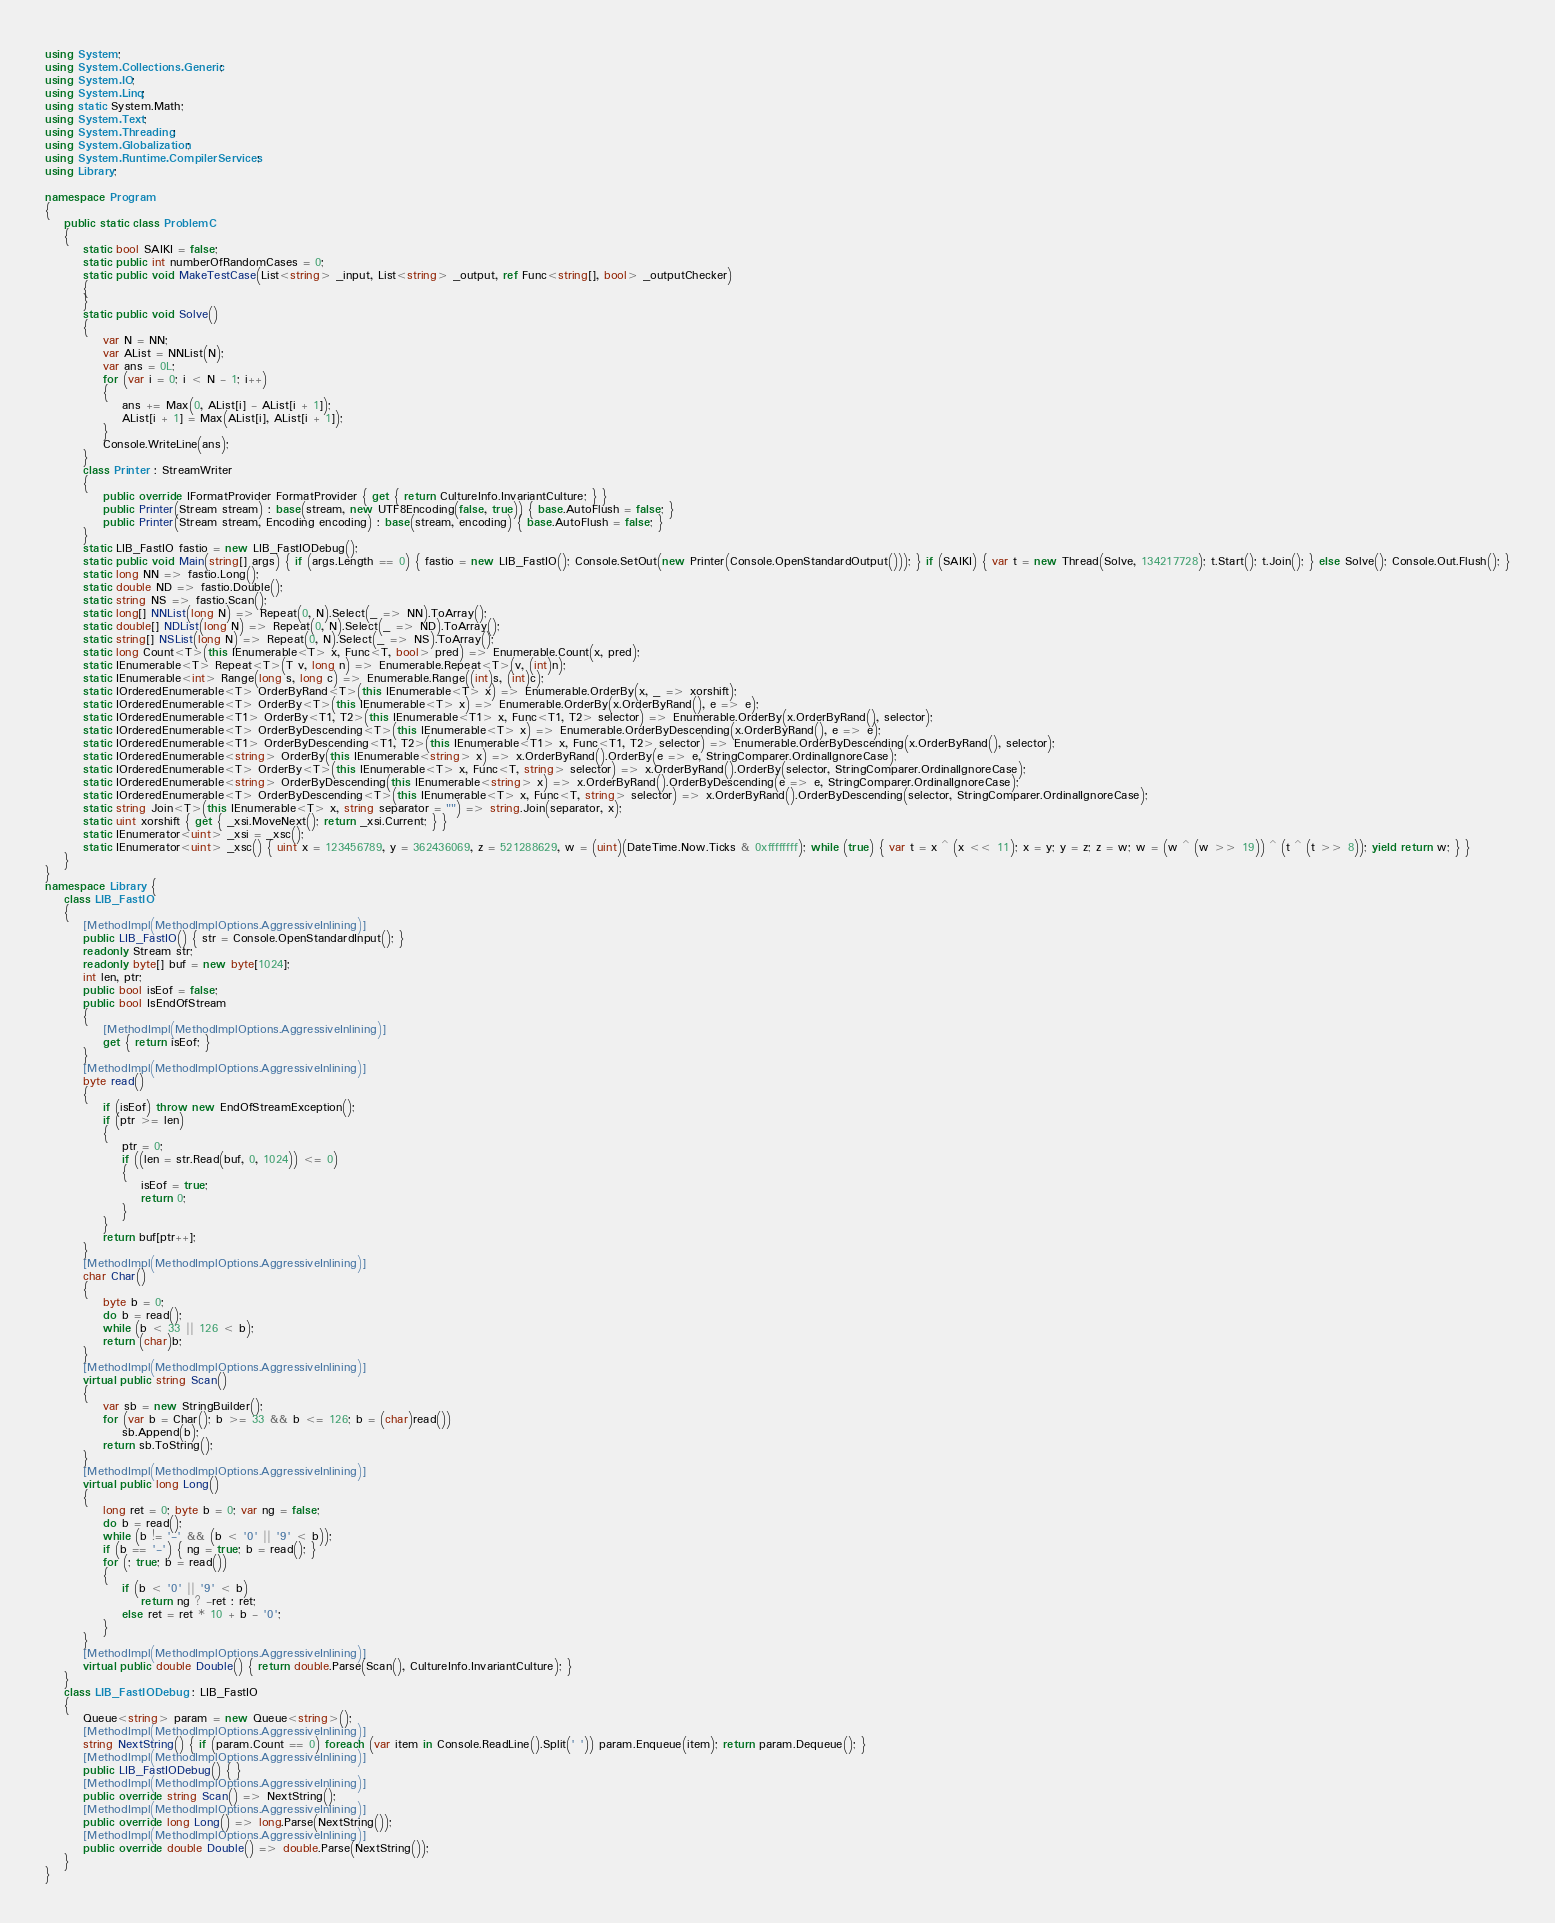<code> <loc_0><loc_0><loc_500><loc_500><_C#_>using System;
using System.Collections.Generic;
using System.IO;
using System.Linq;
using static System.Math;
using System.Text;
using System.Threading;
using System.Globalization;
using System.Runtime.CompilerServices;
using Library;

namespace Program
{
    public static class ProblemC
    {
        static bool SAIKI = false;
        static public int numberOfRandomCases = 0;
        static public void MakeTestCase(List<string> _input, List<string> _output, ref Func<string[], bool> _outputChecker)
        {
        }
        static public void Solve()
        {
            var N = NN;
            var AList = NNList(N);
            var ans = 0L;
            for (var i = 0; i < N - 1; i++)
            {
                ans += Max(0, AList[i] - AList[i + 1]);
                AList[i + 1] = Max(AList[i], AList[i + 1]);
            }
            Console.WriteLine(ans);
        }
        class Printer : StreamWriter
        {
            public override IFormatProvider FormatProvider { get { return CultureInfo.InvariantCulture; } }
            public Printer(Stream stream) : base(stream, new UTF8Encoding(false, true)) { base.AutoFlush = false; }
            public Printer(Stream stream, Encoding encoding) : base(stream, encoding) { base.AutoFlush = false; }
        }
        static LIB_FastIO fastio = new LIB_FastIODebug();
        static public void Main(string[] args) { if (args.Length == 0) { fastio = new LIB_FastIO(); Console.SetOut(new Printer(Console.OpenStandardOutput())); } if (SAIKI) { var t = new Thread(Solve, 134217728); t.Start(); t.Join(); } else Solve(); Console.Out.Flush(); }
        static long NN => fastio.Long();
        static double ND => fastio.Double();
        static string NS => fastio.Scan();
        static long[] NNList(long N) => Repeat(0, N).Select(_ => NN).ToArray();
        static double[] NDList(long N) => Repeat(0, N).Select(_ => ND).ToArray();
        static string[] NSList(long N) => Repeat(0, N).Select(_ => NS).ToArray();
        static long Count<T>(this IEnumerable<T> x, Func<T, bool> pred) => Enumerable.Count(x, pred);
        static IEnumerable<T> Repeat<T>(T v, long n) => Enumerable.Repeat<T>(v, (int)n);
        static IEnumerable<int> Range(long s, long c) => Enumerable.Range((int)s, (int)c);
        static IOrderedEnumerable<T> OrderByRand<T>(this IEnumerable<T> x) => Enumerable.OrderBy(x, _ => xorshift);
        static IOrderedEnumerable<T> OrderBy<T>(this IEnumerable<T> x) => Enumerable.OrderBy(x.OrderByRand(), e => e);
        static IOrderedEnumerable<T1> OrderBy<T1, T2>(this IEnumerable<T1> x, Func<T1, T2> selector) => Enumerable.OrderBy(x.OrderByRand(), selector);
        static IOrderedEnumerable<T> OrderByDescending<T>(this IEnumerable<T> x) => Enumerable.OrderByDescending(x.OrderByRand(), e => e);
        static IOrderedEnumerable<T1> OrderByDescending<T1, T2>(this IEnumerable<T1> x, Func<T1, T2> selector) => Enumerable.OrderByDescending(x.OrderByRand(), selector);
        static IOrderedEnumerable<string> OrderBy(this IEnumerable<string> x) => x.OrderByRand().OrderBy(e => e, StringComparer.OrdinalIgnoreCase);
        static IOrderedEnumerable<T> OrderBy<T>(this IEnumerable<T> x, Func<T, string> selector) => x.OrderByRand().OrderBy(selector, StringComparer.OrdinalIgnoreCase);
        static IOrderedEnumerable<string> OrderByDescending(this IEnumerable<string> x) => x.OrderByRand().OrderByDescending(e => e, StringComparer.OrdinalIgnoreCase);
        static IOrderedEnumerable<T> OrderByDescending<T>(this IEnumerable<T> x, Func<T, string> selector) => x.OrderByRand().OrderByDescending(selector, StringComparer.OrdinalIgnoreCase);
        static string Join<T>(this IEnumerable<T> x, string separator = "") => string.Join(separator, x);
        static uint xorshift { get { _xsi.MoveNext(); return _xsi.Current; } }
        static IEnumerator<uint> _xsi = _xsc();
        static IEnumerator<uint> _xsc() { uint x = 123456789, y = 362436069, z = 521288629, w = (uint)(DateTime.Now.Ticks & 0xffffffff); while (true) { var t = x ^ (x << 11); x = y; y = z; z = w; w = (w ^ (w >> 19)) ^ (t ^ (t >> 8)); yield return w; } }
    }
}
namespace Library {
    class LIB_FastIO
    {
        [MethodImpl(MethodImplOptions.AggressiveInlining)]
        public LIB_FastIO() { str = Console.OpenStandardInput(); }
        readonly Stream str;
        readonly byte[] buf = new byte[1024];
        int len, ptr;
        public bool isEof = false;
        public bool IsEndOfStream
        {
            [MethodImpl(MethodImplOptions.AggressiveInlining)]
            get { return isEof; }
        }
        [MethodImpl(MethodImplOptions.AggressiveInlining)]
        byte read()
        {
            if (isEof) throw new EndOfStreamException();
            if (ptr >= len)
            {
                ptr = 0;
                if ((len = str.Read(buf, 0, 1024)) <= 0)
                {
                    isEof = true;
                    return 0;
                }
            }
            return buf[ptr++];
        }
        [MethodImpl(MethodImplOptions.AggressiveInlining)]
        char Char()
        {
            byte b = 0;
            do b = read();
            while (b < 33 || 126 < b);
            return (char)b;
        }
        [MethodImpl(MethodImplOptions.AggressiveInlining)]
        virtual public string Scan()
        {
            var sb = new StringBuilder();
            for (var b = Char(); b >= 33 && b <= 126; b = (char)read())
                sb.Append(b);
            return sb.ToString();
        }
        [MethodImpl(MethodImplOptions.AggressiveInlining)]
        virtual public long Long()
        {
            long ret = 0; byte b = 0; var ng = false;
            do b = read();
            while (b != '-' && (b < '0' || '9' < b));
            if (b == '-') { ng = true; b = read(); }
            for (; true; b = read())
            {
                if (b < '0' || '9' < b)
                    return ng ? -ret : ret;
                else ret = ret * 10 + b - '0';
            }
        }
        [MethodImpl(MethodImplOptions.AggressiveInlining)]
        virtual public double Double() { return double.Parse(Scan(), CultureInfo.InvariantCulture); }
    }
    class LIB_FastIODebug : LIB_FastIO
    {
        Queue<string> param = new Queue<string>();
        [MethodImpl(MethodImplOptions.AggressiveInlining)]
        string NextString() { if (param.Count == 0) foreach (var item in Console.ReadLine().Split(' ')) param.Enqueue(item); return param.Dequeue(); }
        [MethodImpl(MethodImplOptions.AggressiveInlining)]
        public LIB_FastIODebug() { }
        [MethodImpl(MethodImplOptions.AggressiveInlining)]
        public override string Scan() => NextString();
        [MethodImpl(MethodImplOptions.AggressiveInlining)]
        public override long Long() => long.Parse(NextString());
        [MethodImpl(MethodImplOptions.AggressiveInlining)]
        public override double Double() => double.Parse(NextString());
    }
}
</code> 